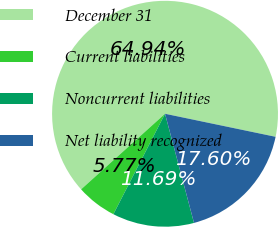Convert chart. <chart><loc_0><loc_0><loc_500><loc_500><pie_chart><fcel>December 31<fcel>Current liabilities<fcel>Noncurrent liabilities<fcel>Net liability recognized<nl><fcel>64.94%<fcel>5.77%<fcel>11.69%<fcel>17.6%<nl></chart> 